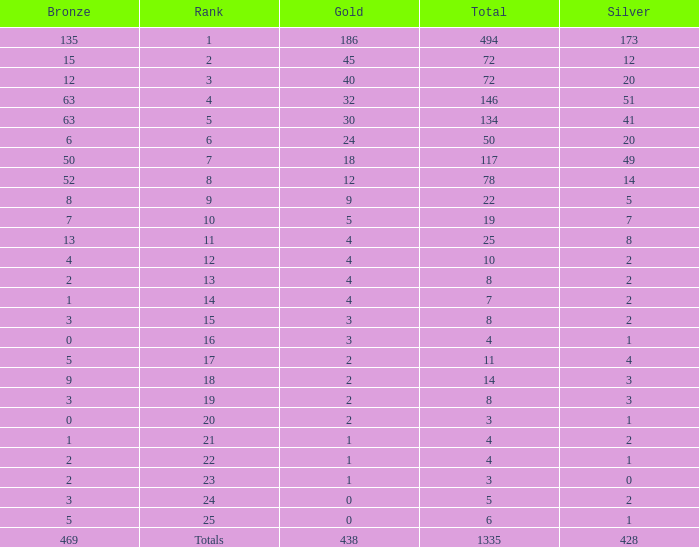What is the total amount of gold medals when there were more than 20 silvers and there were 135 bronze medals? 1.0. 